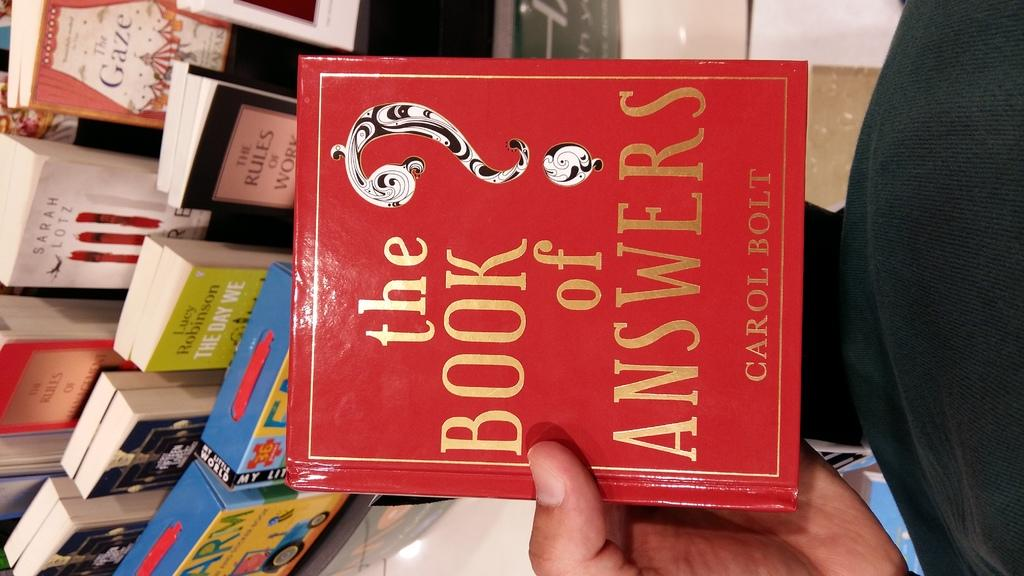<image>
Offer a succinct explanation of the picture presented. the word book is on the front of the book 